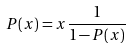Convert formula to latex. <formula><loc_0><loc_0><loc_500><loc_500>P ( x ) = x \frac { 1 } { 1 - P ( x ) }</formula> 